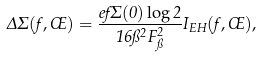Convert formula to latex. <formula><loc_0><loc_0><loc_500><loc_500>\Delta \Sigma ( f , \phi ) = \frac { e f \Sigma ( 0 ) \log 2 } { 1 6 \pi ^ { 2 } F _ { \pi } ^ { 2 } } I _ { E H } ( f , \phi ) ,</formula> 